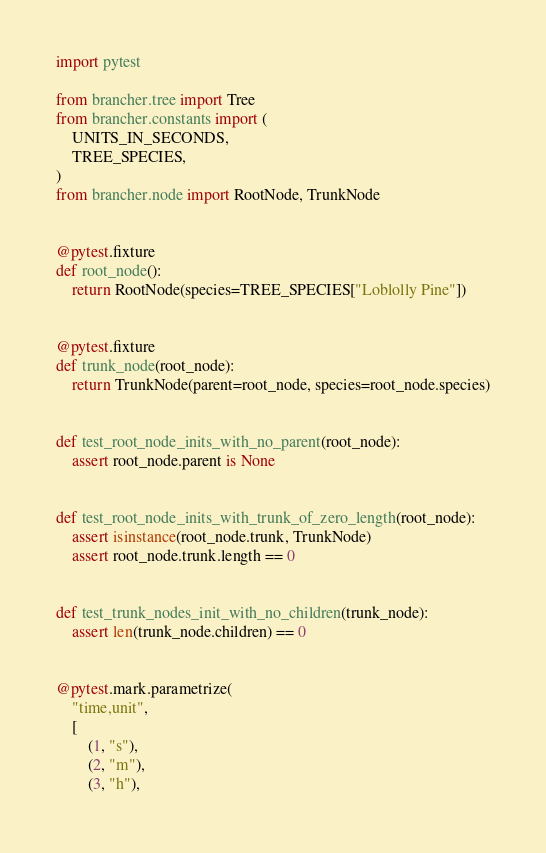Convert code to text. <code><loc_0><loc_0><loc_500><loc_500><_Python_>import pytest

from brancher.tree import Tree
from brancher.constants import (
    UNITS_IN_SECONDS,
    TREE_SPECIES,
)
from brancher.node import RootNode, TrunkNode


@pytest.fixture
def root_node():
    return RootNode(species=TREE_SPECIES["Loblolly Pine"])


@pytest.fixture
def trunk_node(root_node):
    return TrunkNode(parent=root_node, species=root_node.species)


def test_root_node_inits_with_no_parent(root_node):
    assert root_node.parent is None


def test_root_node_inits_with_trunk_of_zero_length(root_node):
    assert isinstance(root_node.trunk, TrunkNode)
    assert root_node.trunk.length == 0


def test_trunk_nodes_init_with_no_children(trunk_node):
    assert len(trunk_node.children) == 0


@pytest.mark.parametrize(
    "time,unit",
    [
        (1, "s"),
        (2, "m"),
        (3, "h"),</code> 